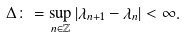<formula> <loc_0><loc_0><loc_500><loc_500>\Delta \colon = \sup _ { n \in \mathbb { Z } } | \lambda _ { n + 1 } - \lambda _ { n } | < \infty .</formula> 